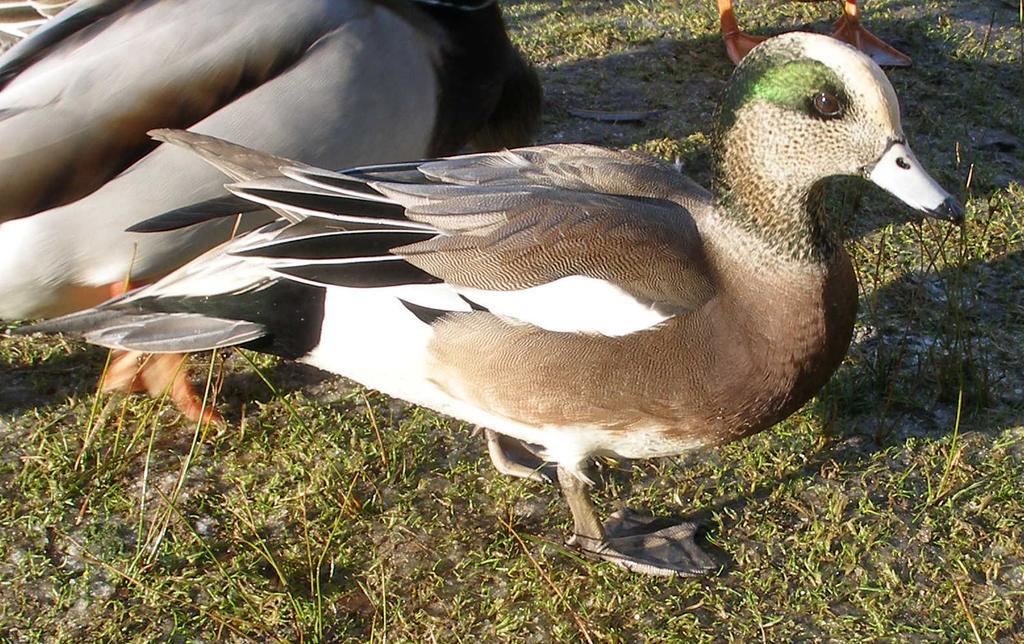Please provide a concise description of this image. In this image I see ducks which are of white, brown, black and green in color and I see the grass. 